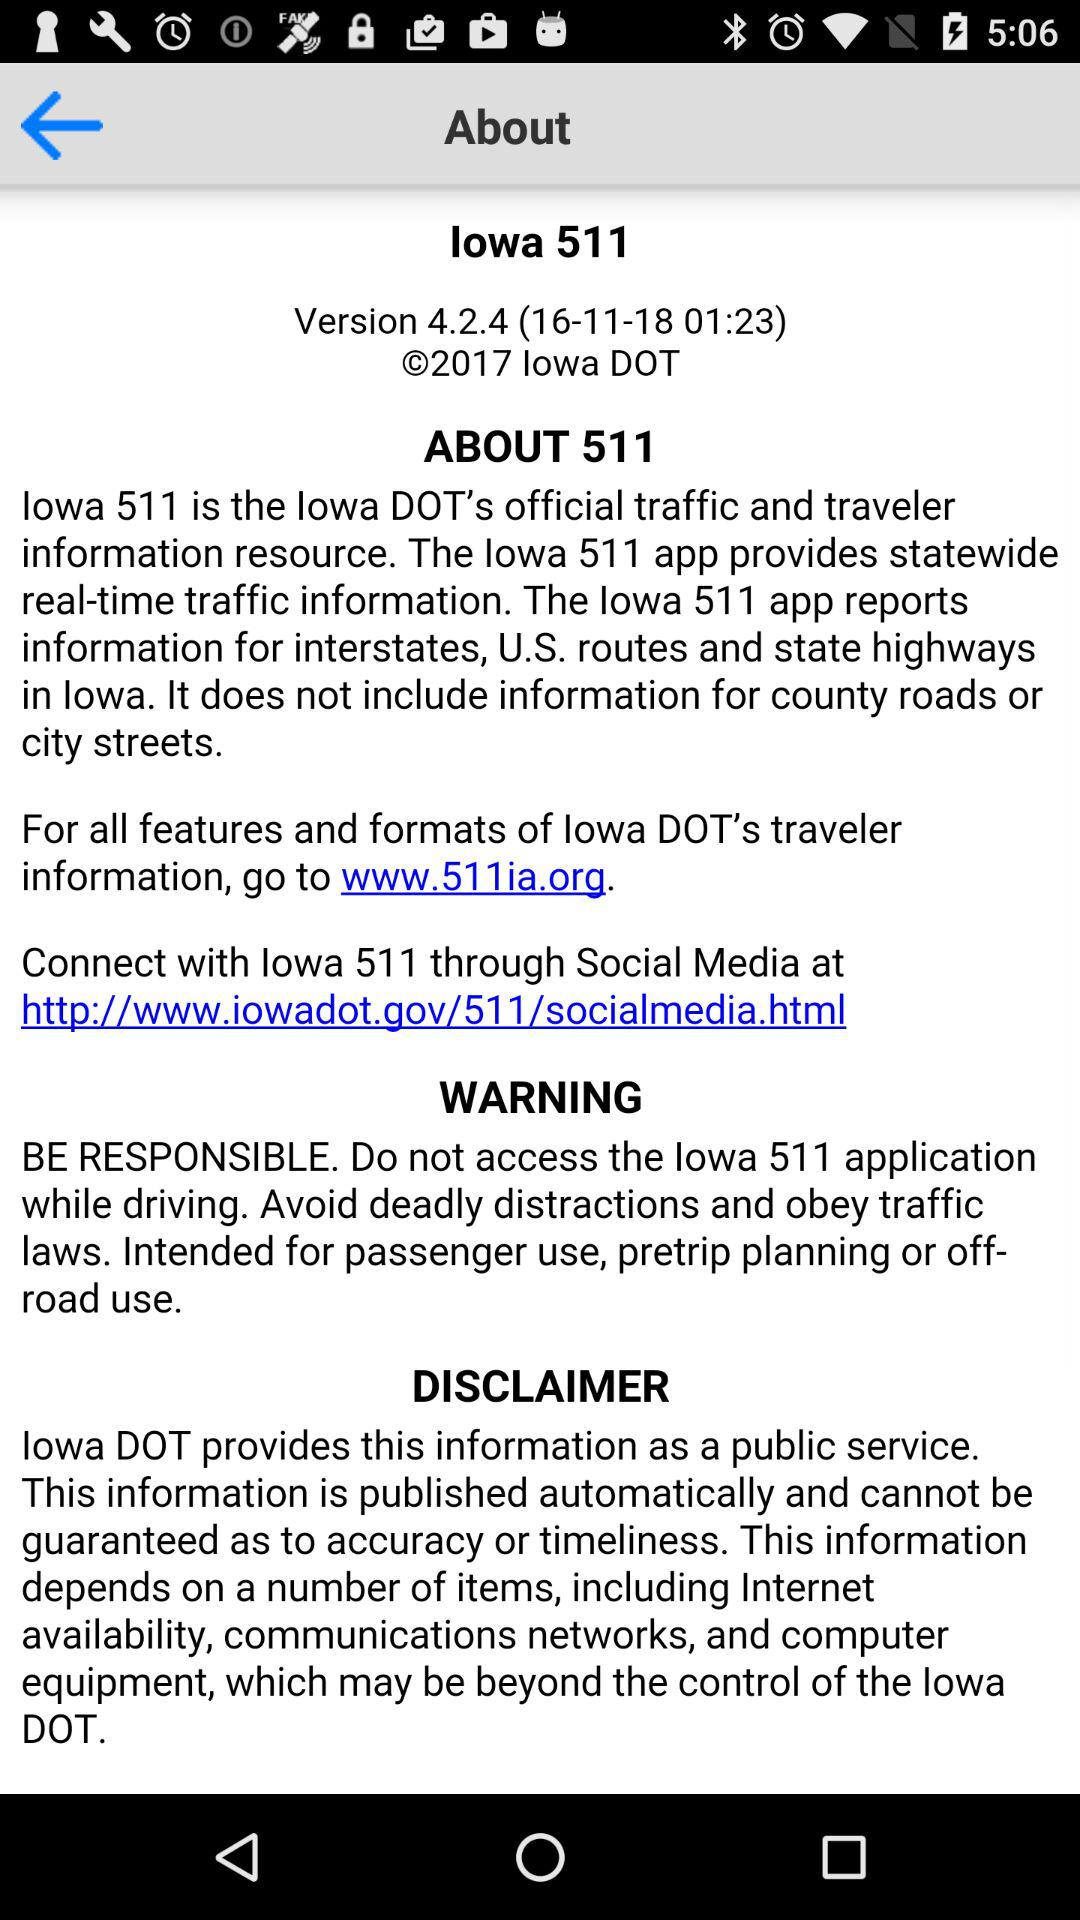What website can I visit for more information about "Iowa DOT"? You can visit www.511ia.org for more information about "Iowa DOT". 